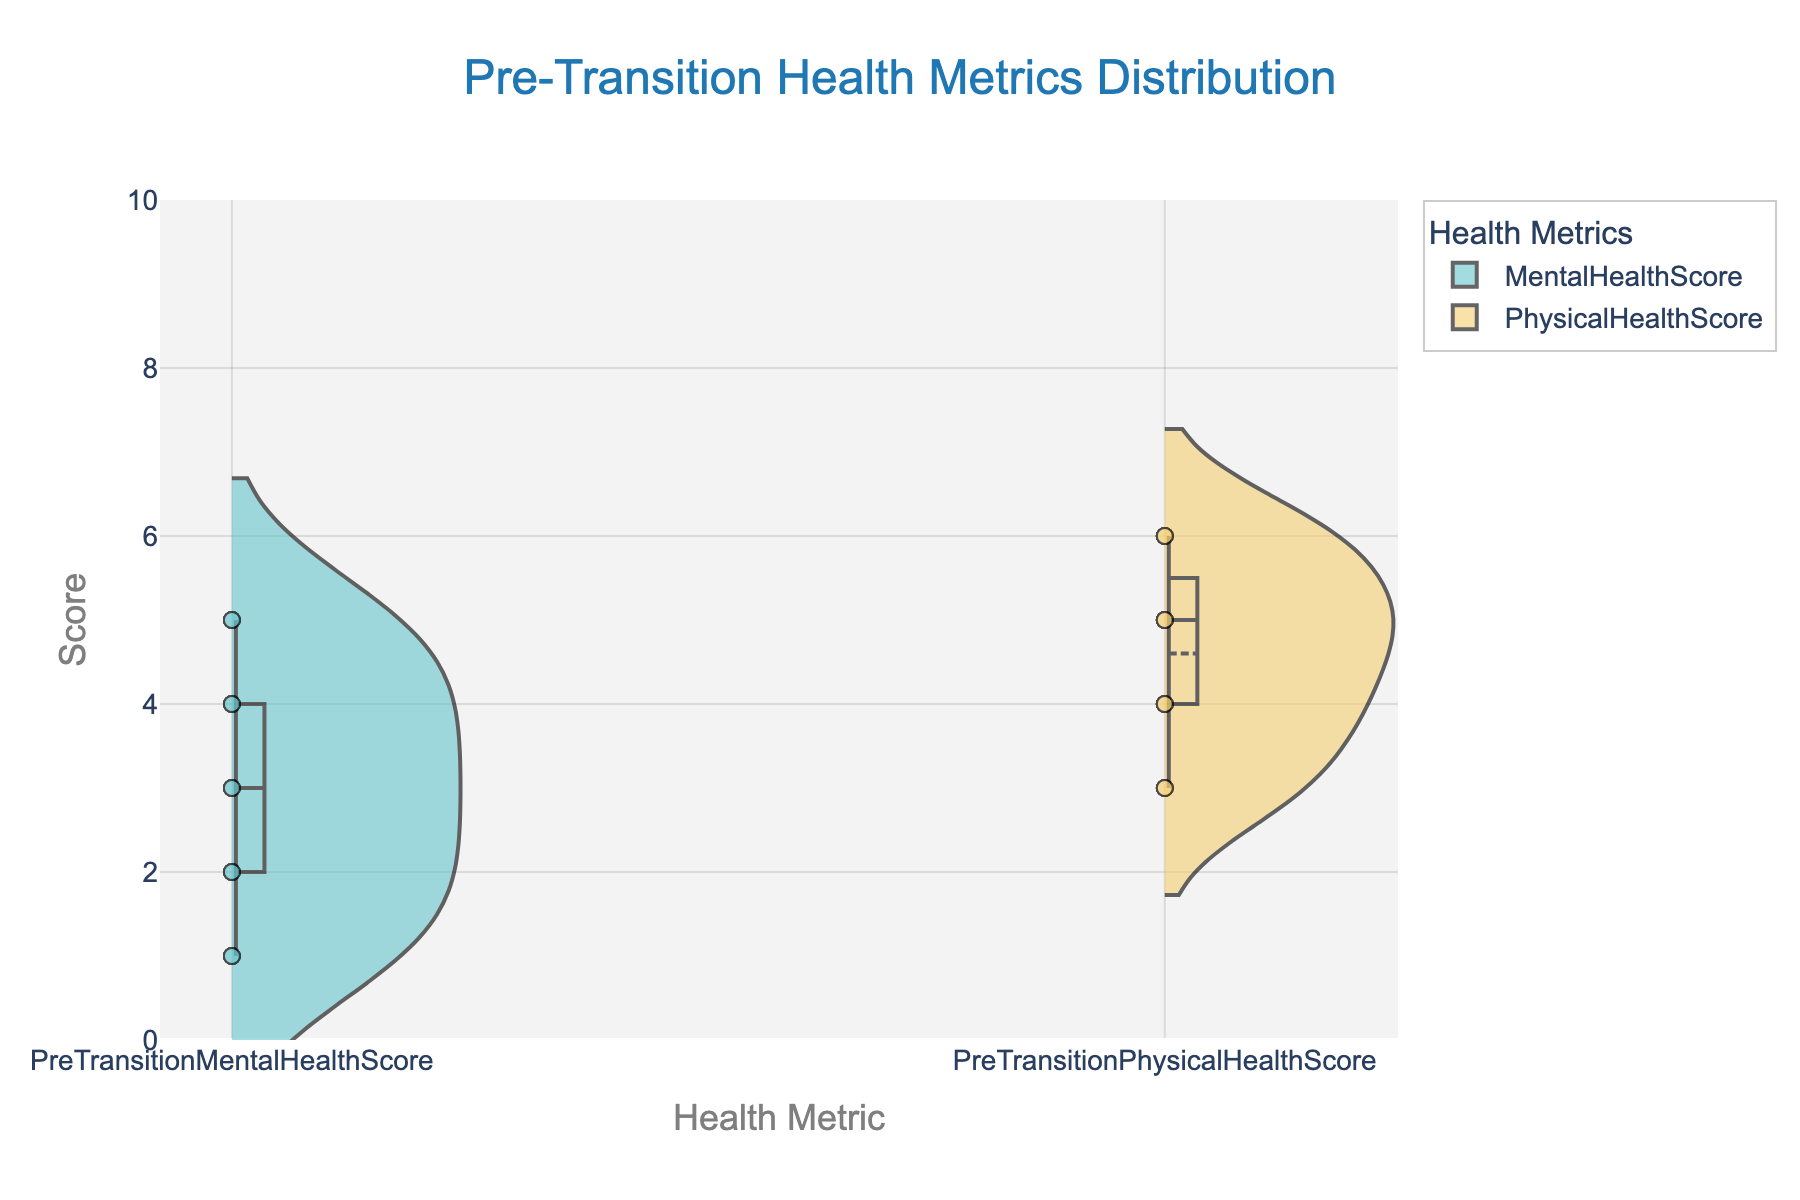What's the title of the figure? The title is usually located at the top of the figure and is intended to provide a summary of what the figure is about. By looking at the top part of the figure, you can see the text 'Pre-Transition Health Metrics Distribution'.
Answer: Pre-Transition Health Metrics Distribution What is the range of the y-axis? The y-axis usually runs vertically and by looking at its markers and labels, we observe that the y-axis ranges from 0 to 10.
Answer: 0 to 10 Which pre-transition health metric shows higher variability in scores? The width and spread of the violin plots indicate variability. By comparing the spreads, we can see that the 'Mental Health Score' has a wider distribution compared to the 'Physical Health Score'.
Answer: Mental Health Score Are the mean scores for both health metrics visible in the figure? The mean scores are typically indicated by a horizontal line within the violin plot. Since each violin plot has a meanline visible, it confirms that both mean scores are clearly displayed.
Answer: Yes Which health metric tends to have higher overall scores? By visually comparing the medians and the overall distribution of both violin plots, it's evident that the 'Physical Health Score' tends to have higher scores than 'Mental Health Score'.
Answer: Physical Health Score How many different categories of health metrics are displayed in the figure? By looking at the x-axis labels, we can see that there are two distinct categories: 'Mental Health Score' and 'Physical Health Score'.
Answer: Two What is the lowest score recorded for Mental Health Score? For the lowest points, we look at the bottom part of the Mental Health Score's violin plot. The lowest score near the bottom of the plot is 1.
Answer: 1 Are there any visible outliers in the data points for Physical Health Score? Outliers would appear as isolated points far away from the central mass of the violin plot. No such points are observed outside the primary distribution, indicating no visible outliers for Physical Health Score.
Answer: No Which health metric has a median closer to the upper end of the scale? The median is represented by the thick line in the middle of each violin plot. By comparing the positions of these lines, it's clear that the median for the 'Physical Health Score' is closer to the upper end of the scale.
Answer: Physical Health Score What can you infer about the distribution symmetry of both health metrics? Symmetry in distribution can be assessed by comparing both sides of the violin plot. The Physical Health Score plot looks more symmetrical, whereas the Mental Health Score appears slightly skewed.
Answer: Mental Health Score is skewed, Physical Health Score is symmetrical 